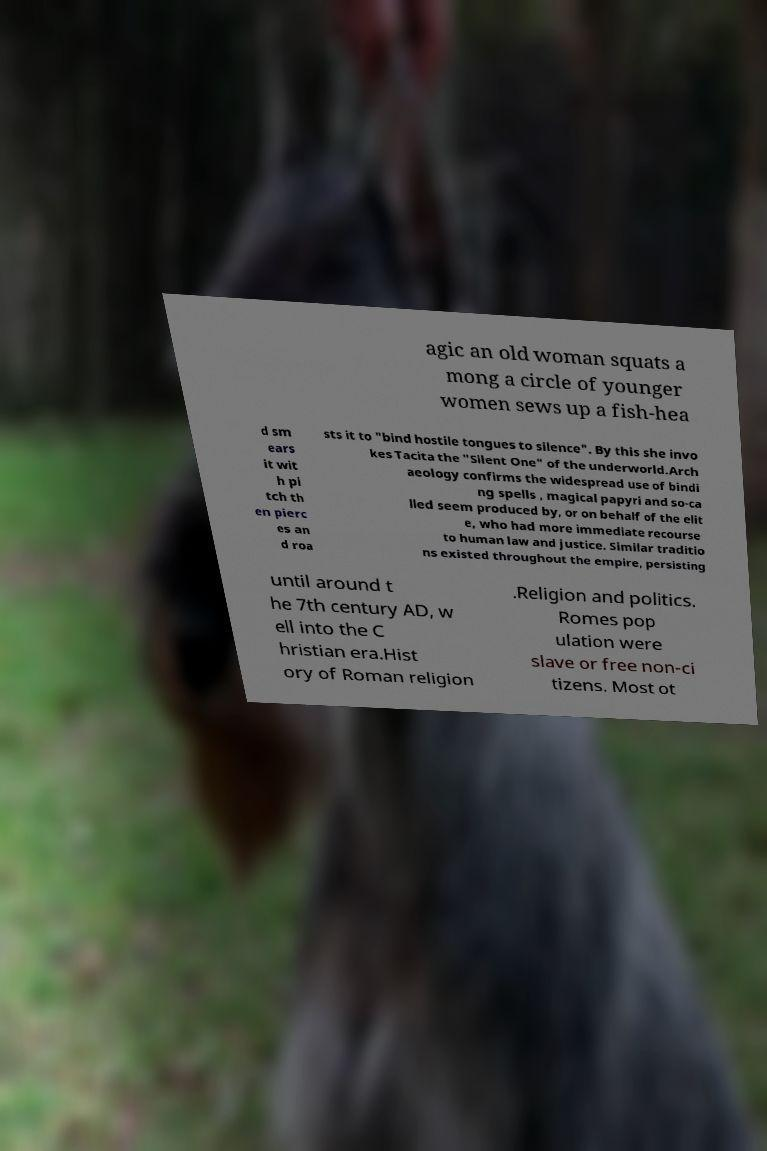For documentation purposes, I need the text within this image transcribed. Could you provide that? agic an old woman squats a mong a circle of younger women sews up a fish-hea d sm ears it wit h pi tch th en pierc es an d roa sts it to "bind hostile tongues to silence". By this she invo kes Tacita the "Silent One" of the underworld.Arch aeology confirms the widespread use of bindi ng spells , magical papyri and so-ca lled seem produced by, or on behalf of the elit e, who had more immediate recourse to human law and justice. Similar traditio ns existed throughout the empire, persisting until around t he 7th century AD, w ell into the C hristian era.Hist ory of Roman religion .Religion and politics. Romes pop ulation were slave or free non-ci tizens. Most ot 